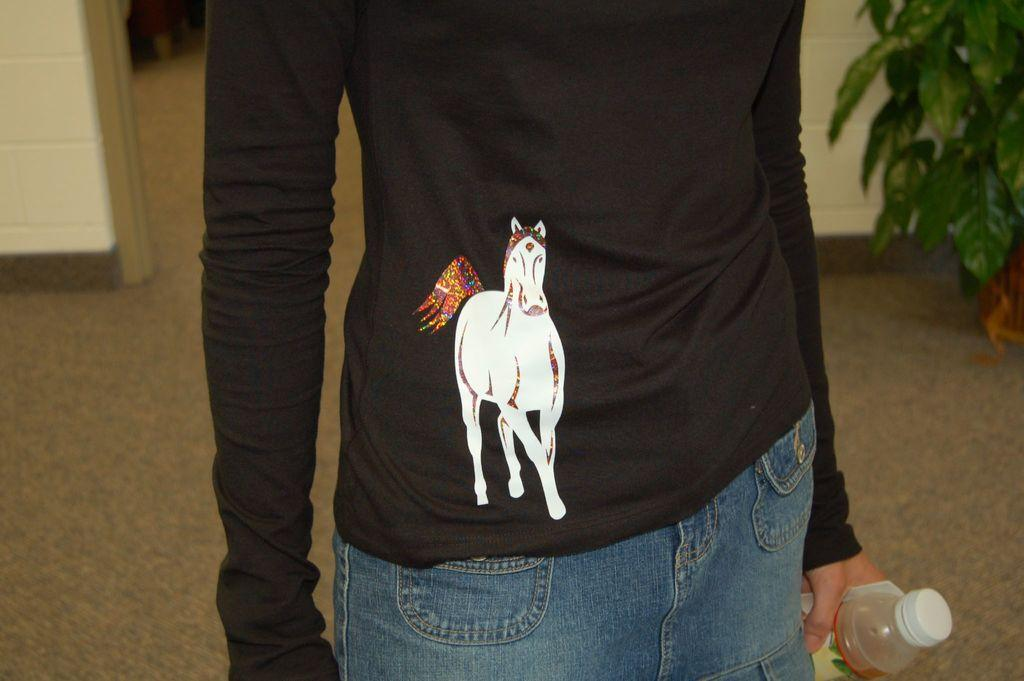What is the person in the image doing? The person is standing in the image. What is the person holding in the image? The person is holding a bottle. What can be seen in the background of the image? There is a wall in the background of the image. What type of vegetation is present in the image? There is a green plant on the right side of the image. What type of boot is the person wearing in the image? There is no boot visible in the image; the person is not wearing any footwear. What is the person's mind thinking about in the image? It is impossible to determine what the person's mind is thinking about based on the image alone. 